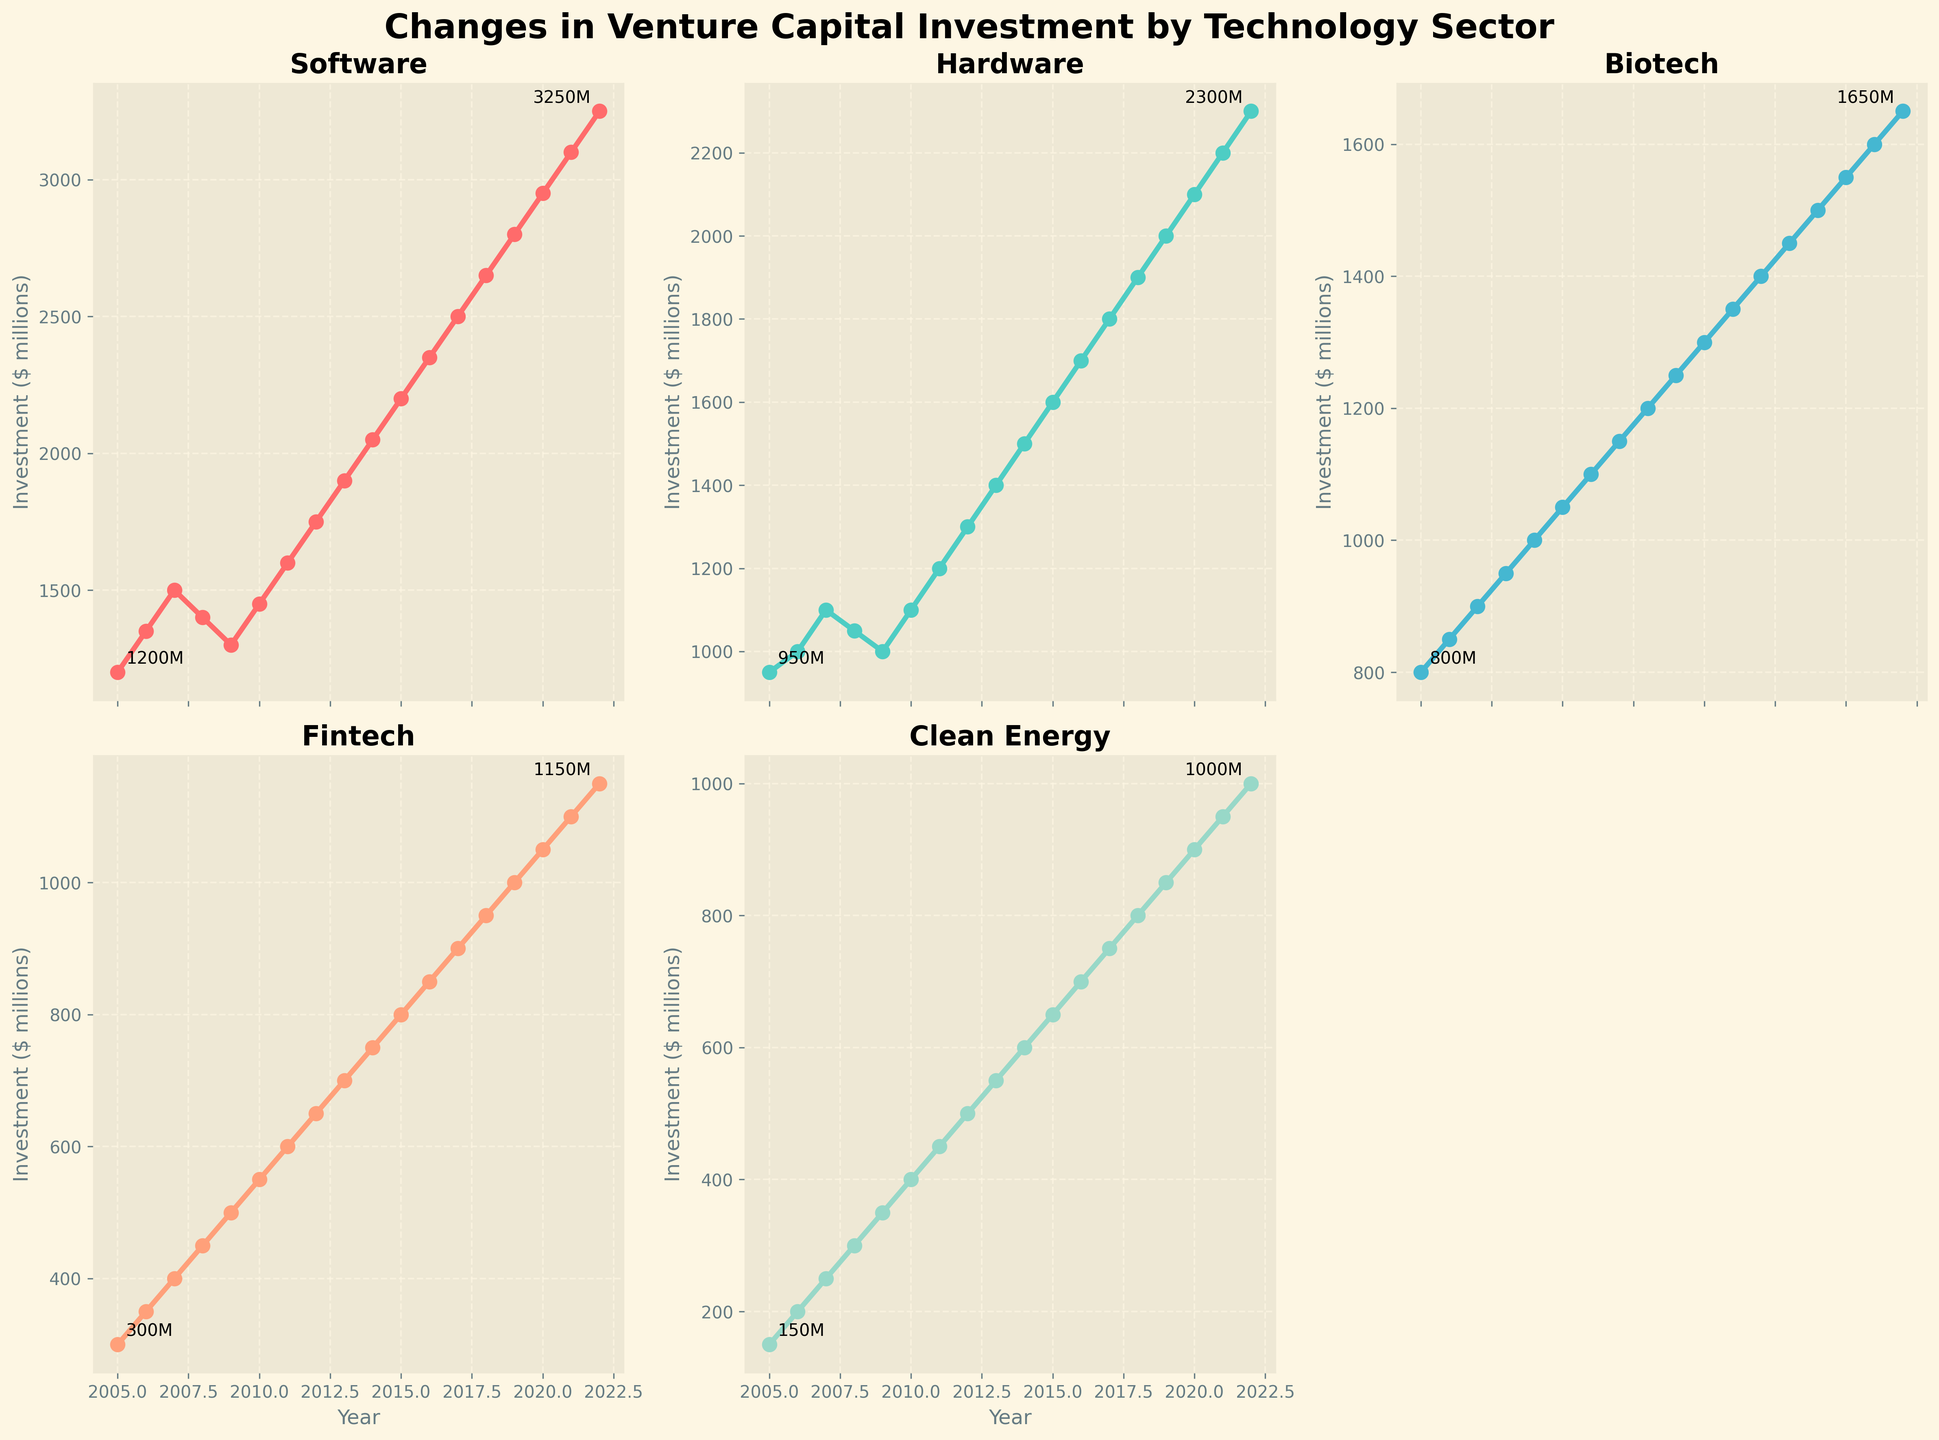What's the overall trend in venture capital investment in the Software sector from 2005 to 2022? The Software sector shows a general upward trend in venture capital investment from 2005 to 2022, starting at $1200 million in 2005 and increasing to $3250 million in 2022, despite a slight dip in 2008 and 2009.
Answer: Upward Which sector had the highest venture capital investment in 2022? By looking at the endpoint of each line on the graph in 2022, the Software sector had the highest investment of $3250 million.
Answer: Software What is the difference in venture capital investment between the Clean Energy and Biotech sectors in 2015? In 2015, Clean Energy had $650 million, whereas Biotech had $1300 million. The difference is $1300 million - $650 million = $650 million.
Answer: $650 million Which sector shows a steady increase in venture capital investment without any dips from 2005 to 2022? By visually inspecting the trends of each sector, the Fintech sector shows a steady upward trend without any dips from 2005 to 2022.
Answer: Fintech During which years did the Hardware sector see a decline in venture capital investment? By observing the Hardware line, it had declines in 2008, 2009, and 2020.
Answer: 2008, 2009, 2020 What is the average venture capital investment in the Fintech sector over the entire period from 2005 to 2022? Sum the yearly investments from 2005 to 2022 and divide by the number of years (18). Total is: 300+350+400+450+500+550+600+650+700+750+800+850+900+950+1000+1050+1100+1150 = 13000. Average is 13000/18 ≈ $722.22 million.
Answer: $722.22 million How does the investment growth in Software compare to the growth in Biotech from 2005 to 2022? For Software: $3250 million in 2022 - $1200 million in 2005 = $2050 million increase. For Biotech: $1650 million in 2022 - $800 million in 2005 = $850 million increase. Software growth is significantly higher than Biotech growth.
Answer: Software growth is higher Identify the sector with the smallest percentage increase in venture capital investment from 2005 to 2022. Calculate the percentage increase for each sector. For Clean Energy: [(1000 - 150) / 150] * 100% ≈ 566.67%. Biotech shows [(1650 - 800) / 800] * 100% = 106.25%. Hardware: [(2300 - 950) / 950] * 100% ≈ 142.11%. Software: [(3250 - 1200) / 1200] * 100% ≈ 170.83%. Fintech: [(1150 - 300) / 300] * 100% ≈ 283.33%. Thus, Biotech has the smallest percentage increase.
Answer: Biotech Was there a year when all sectors saw an increase in venture capital investment? By checking each year, 2010, 2014, 2015, 2016, and 2017 are years in which investment increased across all sectors.
Answer: 2010, 2014, 2015, 2016, 2017 